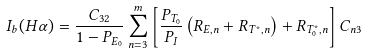Convert formula to latex. <formula><loc_0><loc_0><loc_500><loc_500>I _ { b } ( H \alpha ) = \frac { C _ { 3 2 } } { 1 - P _ { E _ { 0 } } } \sum ^ { m } _ { n = 3 } \left [ \frac { P _ { T _ { 0 } } } { P _ { I } } \left ( R _ { E , n } + R _ { T ^ { * } , n } \right ) + R _ { T ^ { * } _ { 0 } , n } \right ] C _ { n 3 }</formula> 